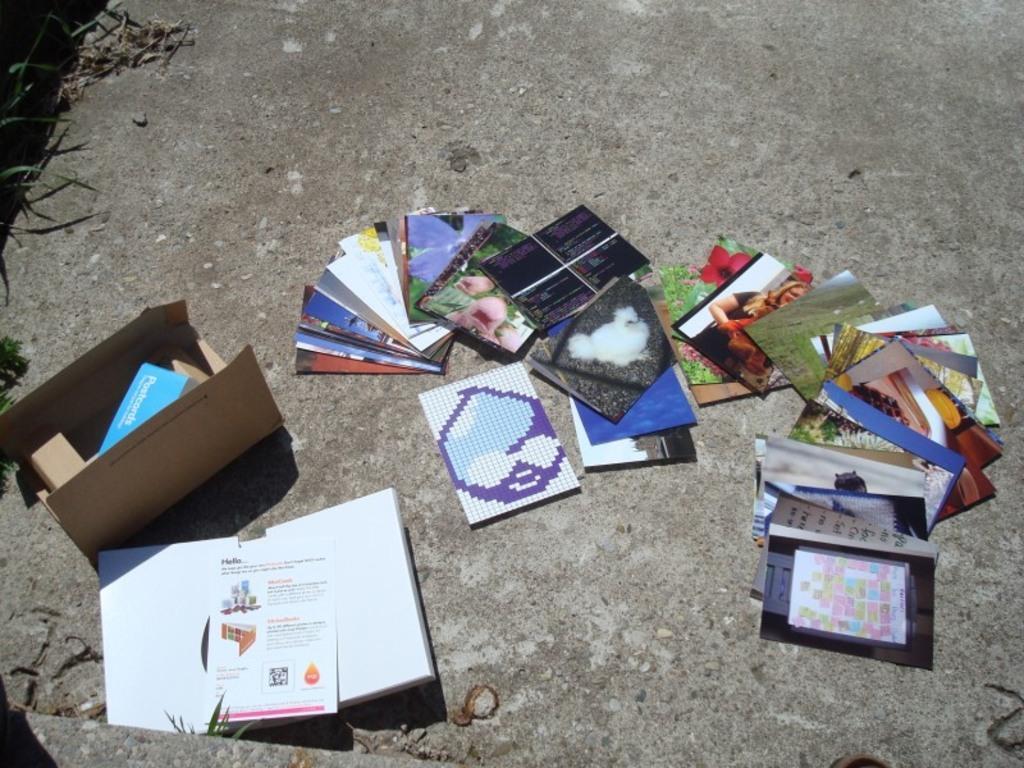Can you describe this image briefly? In this image there are photos, cardboard box, book and few objects are on the land. In the cardboard box there is an object. Left side there is some grass on the land. 